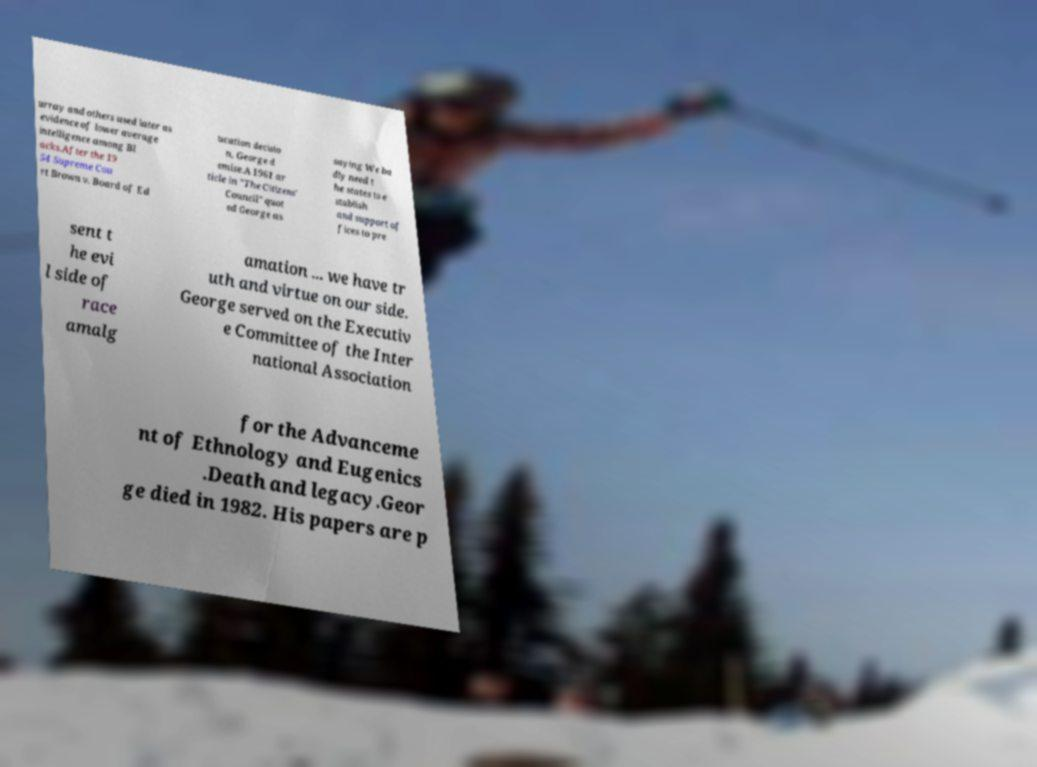What messages or text are displayed in this image? I need them in a readable, typed format. urray and others used later as evidence of lower average intelligence among Bl acks.After the 19 54 Supreme Cou rt Brown v. Board of Ed ucation decisio n, George d emise.A 1961 ar ticle in "The Citizens' Council" quot ed George as saying We ba dly need t he states to e stablish and support of fices to pre sent t he evi l side of race amalg amation ... we have tr uth and virtue on our side. George served on the Executiv e Committee of the Inter national Association for the Advanceme nt of Ethnology and Eugenics .Death and legacy.Geor ge died in 1982. His papers are p 